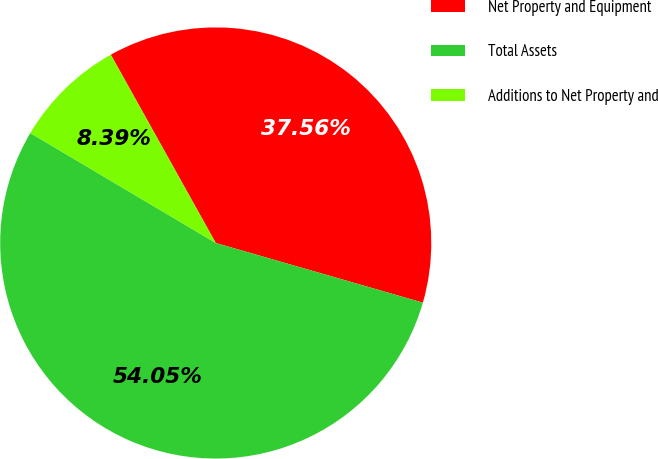Convert chart. <chart><loc_0><loc_0><loc_500><loc_500><pie_chart><fcel>Net Property and Equipment<fcel>Total Assets<fcel>Additions to Net Property and<nl><fcel>37.56%<fcel>54.05%<fcel>8.39%<nl></chart> 